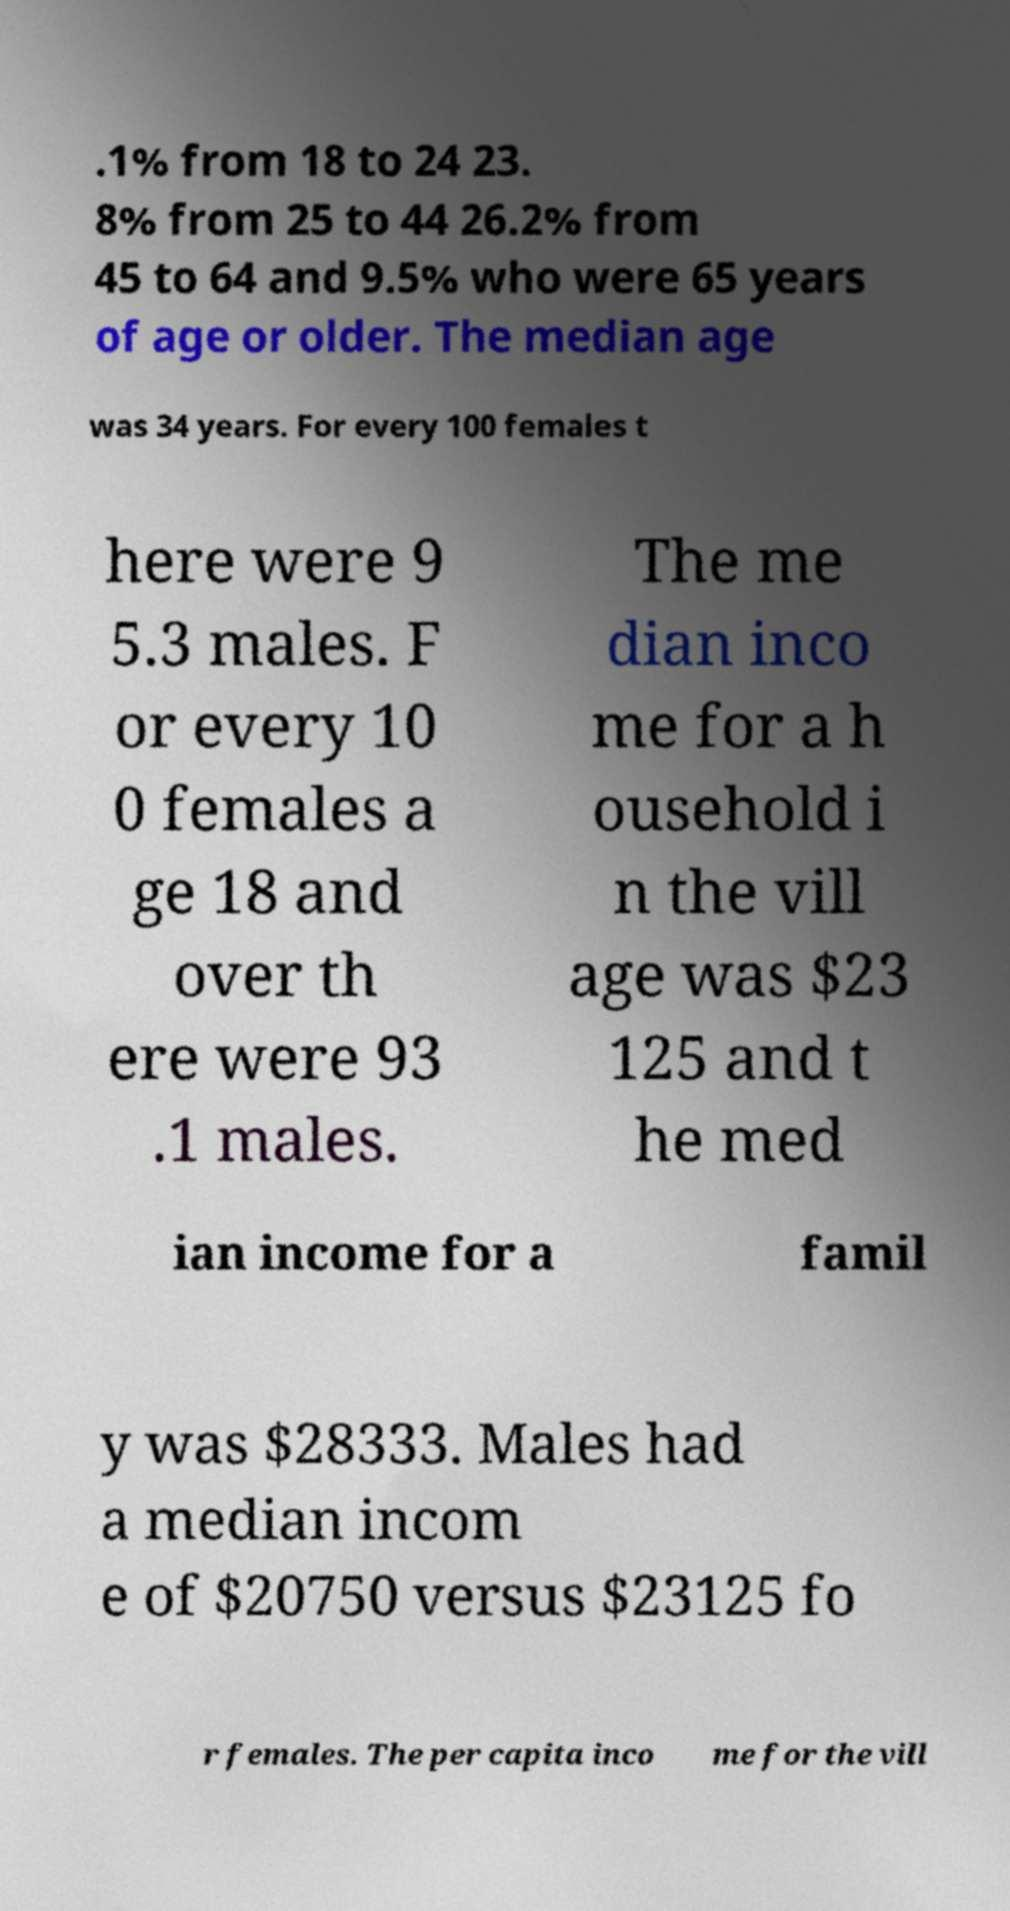Please identify and transcribe the text found in this image. .1% from 18 to 24 23. 8% from 25 to 44 26.2% from 45 to 64 and 9.5% who were 65 years of age or older. The median age was 34 years. For every 100 females t here were 9 5.3 males. F or every 10 0 females a ge 18 and over th ere were 93 .1 males. The me dian inco me for a h ousehold i n the vill age was $23 125 and t he med ian income for a famil y was $28333. Males had a median incom e of $20750 versus $23125 fo r females. The per capita inco me for the vill 